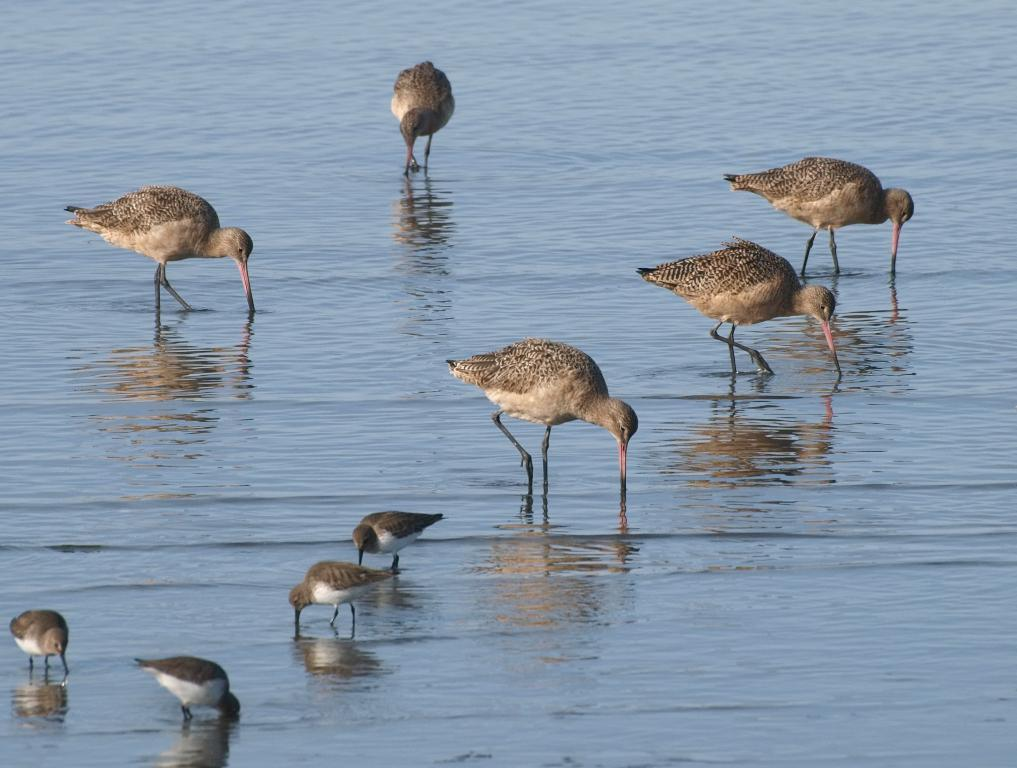What type of animals can be seen in the image? There are birds in the image. Where are the birds located? The birds are standing in water. What are the birds doing in the water? The birds have their beaks near the water. What type of bun can be seen in the image? There is no bun present in the image; it features birds standing in water. What letters are visible on the birds in the image? There are no letters visible on the birds in the image. 